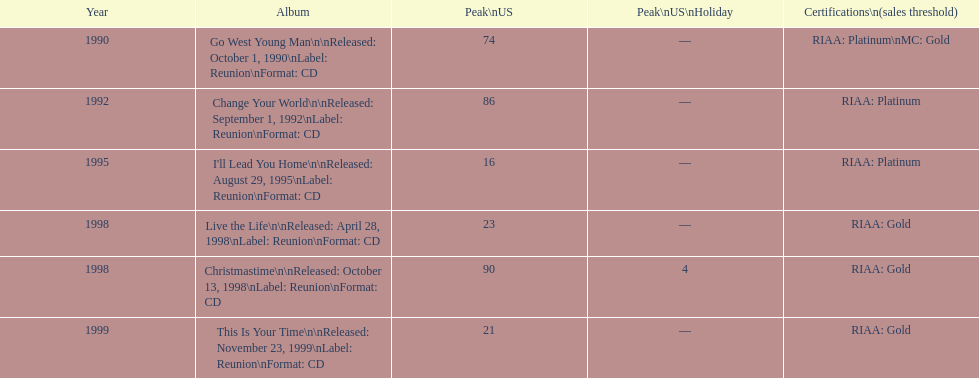Besides riaa gold certification, what is another type of certification? Platinum. 